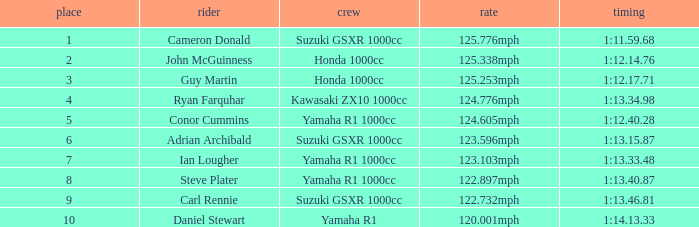What time did team kawasaki zx10 1000cc have? 1:13.34.98. 